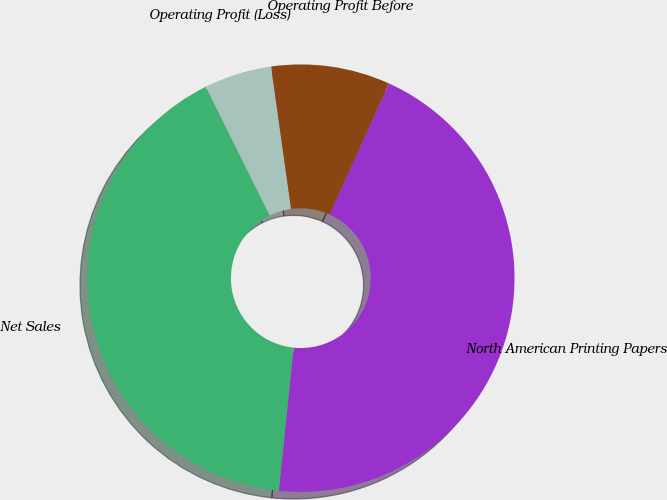Convert chart. <chart><loc_0><loc_0><loc_500><loc_500><pie_chart><fcel>North American Printing Papers<fcel>Net Sales<fcel>Operating Profit (Loss)<fcel>Operating Profit Before<nl><fcel>44.88%<fcel>41.02%<fcel>5.12%<fcel>8.98%<nl></chart> 